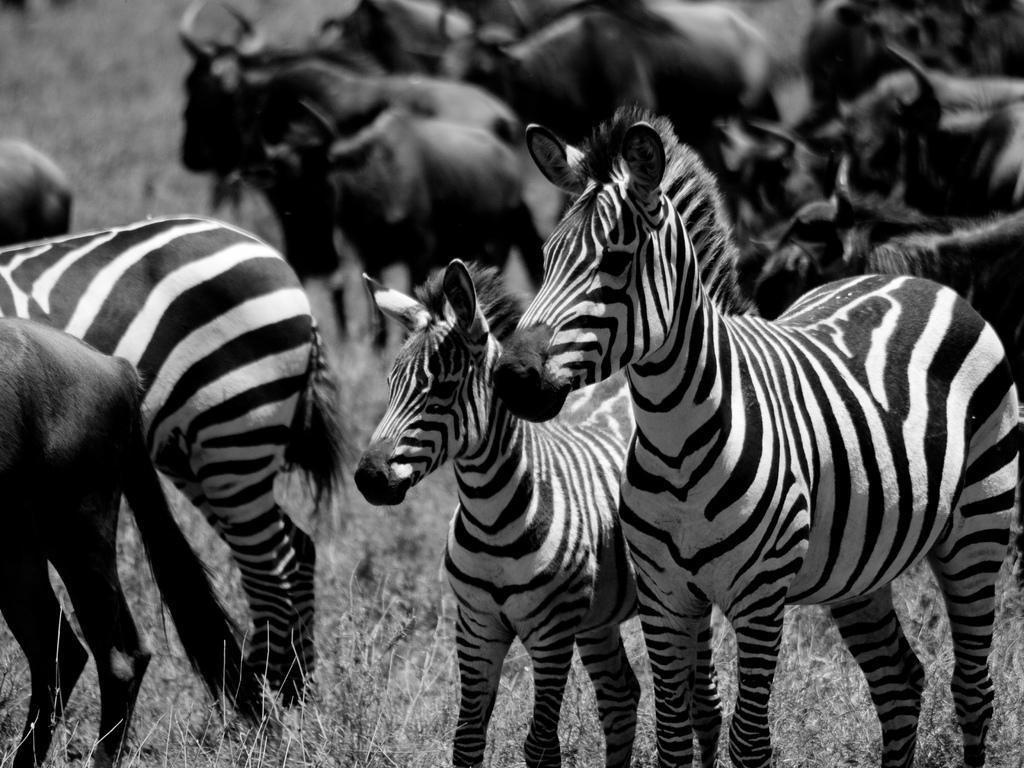What animals are in the foreground of the image? There are zebras and buffaloes in the foreground of the image. What else can be seen in the foreground of the image besides the animals? There are plants in the foreground of the image. Are there any buffaloes visible in the background of the image? Yes, there are buffaloes visible in the background of the image. What type of vase can be seen in the image? There is no vase present in the image. Can you read any writing on the zebras in the image? There is no writing on the zebras in the image. 